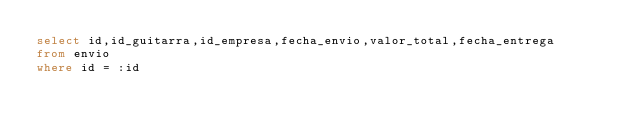<code> <loc_0><loc_0><loc_500><loc_500><_SQL_>select id,id_guitarra,id_empresa,fecha_envio,valor_total,fecha_entrega
from envio
where id = :id</code> 